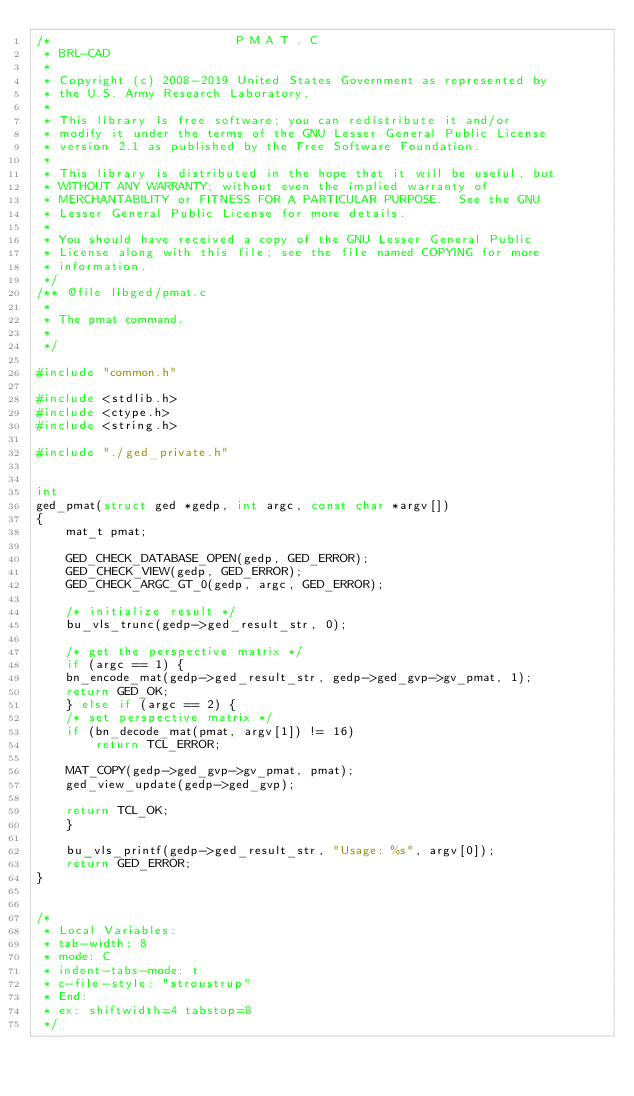Convert code to text. <code><loc_0><loc_0><loc_500><loc_500><_C_>/*                         P M A T . C
 * BRL-CAD
 *
 * Copyright (c) 2008-2019 United States Government as represented by
 * the U.S. Army Research Laboratory.
 *
 * This library is free software; you can redistribute it and/or
 * modify it under the terms of the GNU Lesser General Public License
 * version 2.1 as published by the Free Software Foundation.
 *
 * This library is distributed in the hope that it will be useful, but
 * WITHOUT ANY WARRANTY; without even the implied warranty of
 * MERCHANTABILITY or FITNESS FOR A PARTICULAR PURPOSE.  See the GNU
 * Lesser General Public License for more details.
 *
 * You should have received a copy of the GNU Lesser General Public
 * License along with this file; see the file named COPYING for more
 * information.
 */
/** @file libged/pmat.c
 *
 * The pmat command.
 *
 */

#include "common.h"

#include <stdlib.h>
#include <ctype.h>
#include <string.h>

#include "./ged_private.h"


int
ged_pmat(struct ged *gedp, int argc, const char *argv[])
{
    mat_t pmat;

    GED_CHECK_DATABASE_OPEN(gedp, GED_ERROR);
    GED_CHECK_VIEW(gedp, GED_ERROR);
    GED_CHECK_ARGC_GT_0(gedp, argc, GED_ERROR);

    /* initialize result */
    bu_vls_trunc(gedp->ged_result_str, 0);

    /* get the perspective matrix */
    if (argc == 1) {
	bn_encode_mat(gedp->ged_result_str, gedp->ged_gvp->gv_pmat, 1);
	return GED_OK;
    } else if (argc == 2) {
	/* set perspective matrix */
	if (bn_decode_mat(pmat, argv[1]) != 16)
	    return TCL_ERROR;

	MAT_COPY(gedp->ged_gvp->gv_pmat, pmat);
	ged_view_update(gedp->ged_gvp);

	return TCL_OK;
    }

    bu_vls_printf(gedp->ged_result_str, "Usage: %s", argv[0]);
    return GED_ERROR;
}


/*
 * Local Variables:
 * tab-width: 8
 * mode: C
 * indent-tabs-mode: t
 * c-file-style: "stroustrup"
 * End:
 * ex: shiftwidth=4 tabstop=8
 */
</code> 